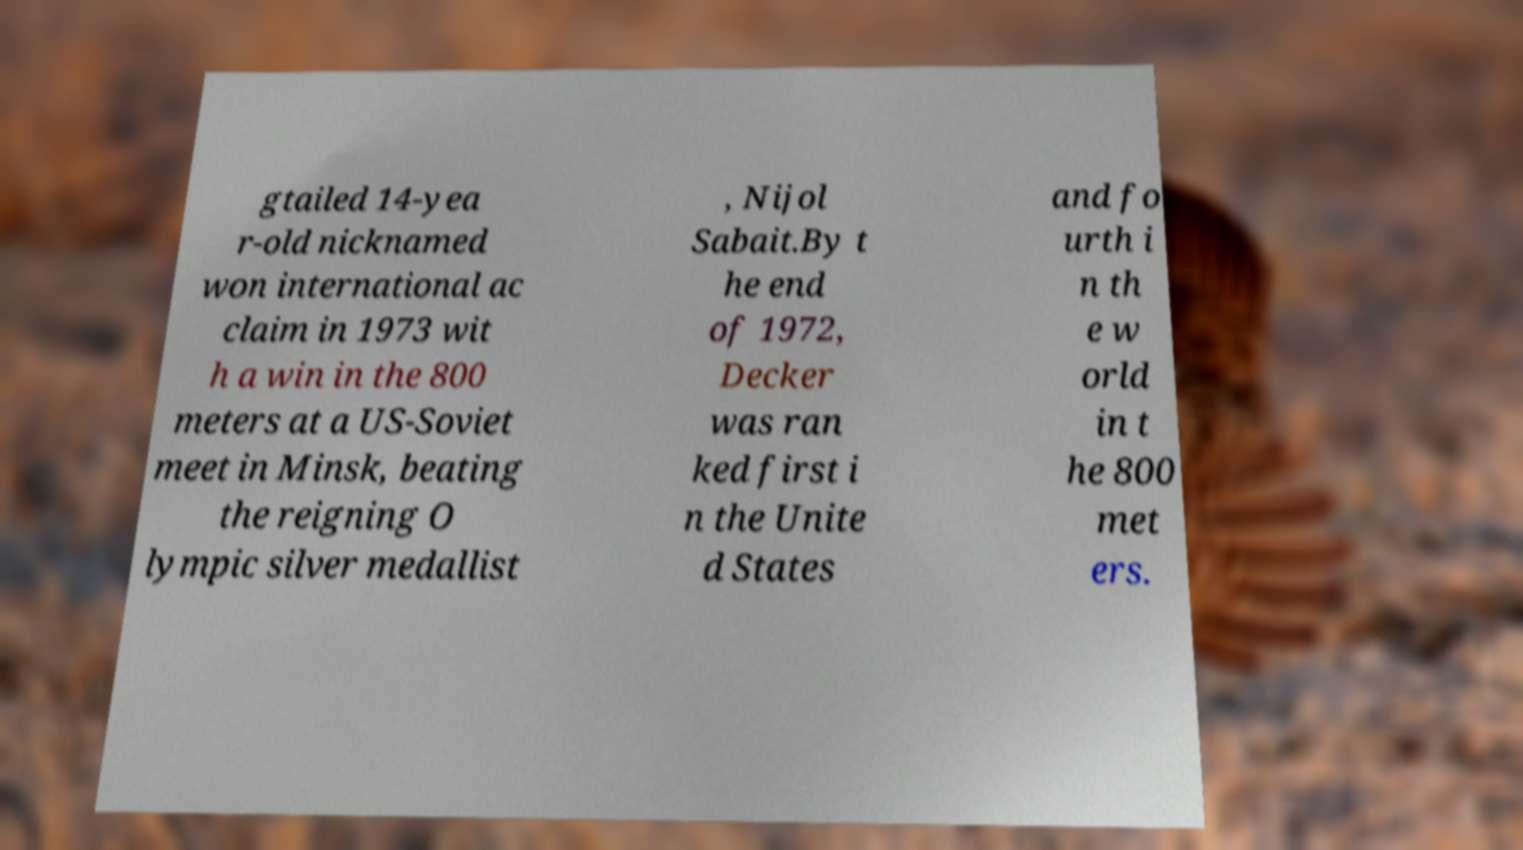For documentation purposes, I need the text within this image transcribed. Could you provide that? gtailed 14-yea r-old nicknamed won international ac claim in 1973 wit h a win in the 800 meters at a US-Soviet meet in Minsk, beating the reigning O lympic silver medallist , Nijol Sabait.By t he end of 1972, Decker was ran ked first i n the Unite d States and fo urth i n th e w orld in t he 800 met ers. 